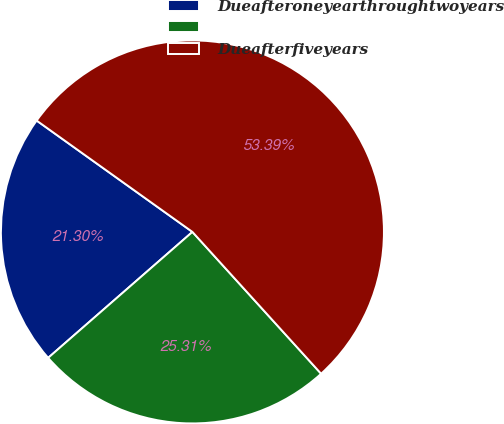Convert chart to OTSL. <chart><loc_0><loc_0><loc_500><loc_500><pie_chart><fcel>Dueafteroneyearthroughtwoyears<fcel>Unnamed: 1<fcel>Dueafterfiveyears<nl><fcel>21.3%<fcel>25.31%<fcel>53.4%<nl></chart> 